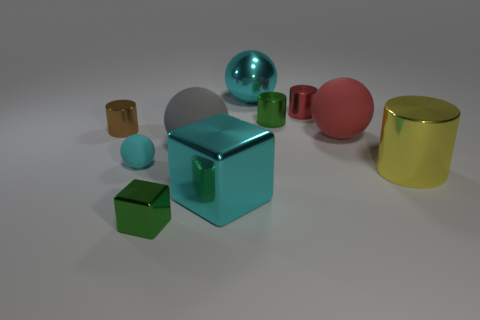Is the color of the metallic sphere the same as the ball that is left of the gray rubber thing?
Ensure brevity in your answer.  Yes. What is the material of the large object that is on the left side of the big red matte ball and to the right of the big block?
Offer a terse response. Metal. Are there any gray rubber balls that have the same size as the shiny ball?
Offer a very short reply. Yes. What is the material of the cylinder that is the same size as the gray sphere?
Your answer should be very brief. Metal. What number of small red metal things are behind the green metal cube?
Offer a terse response. 1. Do the large object behind the red sphere and the gray rubber thing have the same shape?
Provide a succinct answer. Yes. Is there a big green matte thing of the same shape as the yellow thing?
Keep it short and to the point. No. What is the material of the large ball that is the same color as the big cube?
Your response must be concise. Metal. What is the shape of the big metal thing that is behind the big yellow metallic object to the right of the gray thing?
Provide a succinct answer. Sphere. What number of cyan objects are the same material as the large cyan cube?
Offer a very short reply. 1. 